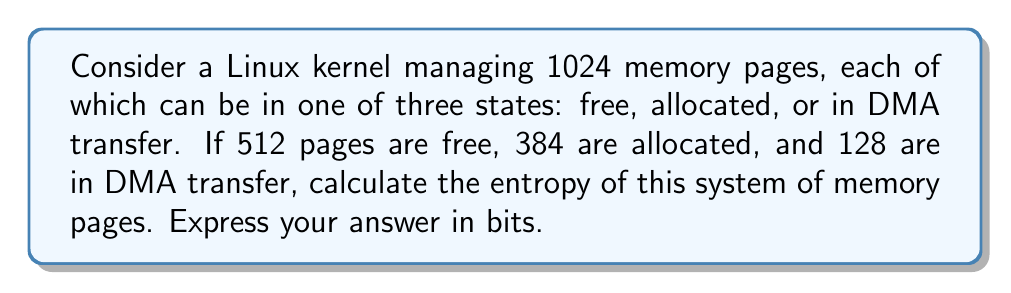Could you help me with this problem? To calculate the entropy of this system, we'll follow these steps:

1. Identify the probabilities for each state:
   $p_{free} = 512/1024 = 1/2$
   $p_{allocated} = 384/1024 = 3/8$
   $p_{DMA} = 128/1024 = 1/8$

2. Apply the entropy formula:
   $$S = -k\sum_{i} p_i \ln p_i$$
   where $k$ is Boltzmann's constant. In information theory, we use $k = 1/\ln(2)$ to express entropy in bits.

3. Calculate the sum:
   $$\begin{align}
   S &= -\frac{1}{\ln(2)} \left(\frac{1}{2}\ln\frac{1}{2} + \frac{3}{8}\ln\frac{3}{8} + \frac{1}{8}\ln\frac{1}{8}\right) \\
   &= -\frac{1}{\ln(2)} \left(-0.5\ln(2) - \frac{3}{8}\ln(3) + \frac{3}{8}\ln(8) - \frac{1}{8}\ln(8)\right) \\
   &= -\frac{1}{\ln(2)} \left(-0.5\ln(2) - \frac{3}{8}\ln(3) + \frac{3}{8}3\ln(2) - \frac{1}{8}3\ln(2)\right) \\
   &= -\frac{1}{\ln(2)} \left(-0.5\ln(2) - \frac{3}{8}\ln(3) + \frac{5}{8}3\ln(2)\right) \\
   &= 0.5 + \frac{3}{8}\frac{\ln(3)}{\ln(2)} + \frac{15}{8} \\
   &\approx 1.5458 \text{ bits}
   \end{align}$$
Answer: 1.5458 bits 